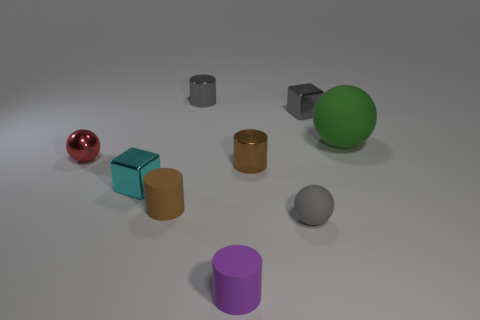Do the big green object and the small red thing have the same material?
Your answer should be very brief. No. There is a rubber thing that is behind the small brown matte cylinder; is there a metal cylinder that is behind it?
Give a very brief answer. Yes. How many cyan things are made of the same material as the tiny purple cylinder?
Offer a very short reply. 0. What size is the rubber sphere behind the brown thing that is on the left side of the purple rubber cylinder in front of the small red sphere?
Make the answer very short. Large. What number of tiny spheres are to the right of the metallic sphere?
Your answer should be very brief. 1. Are there more tiny brown rubber objects than small yellow cylinders?
Offer a very short reply. Yes. What is the size of the metal cylinder that is the same color as the tiny rubber ball?
Provide a succinct answer. Small. How big is the matte object that is on the right side of the purple matte thing and behind the small gray sphere?
Offer a terse response. Large. What is the material of the tiny sphere right of the tiny shiny thing behind the metal block that is behind the small cyan metallic thing?
Make the answer very short. Rubber. What material is the cube that is the same color as the tiny rubber ball?
Offer a terse response. Metal. 